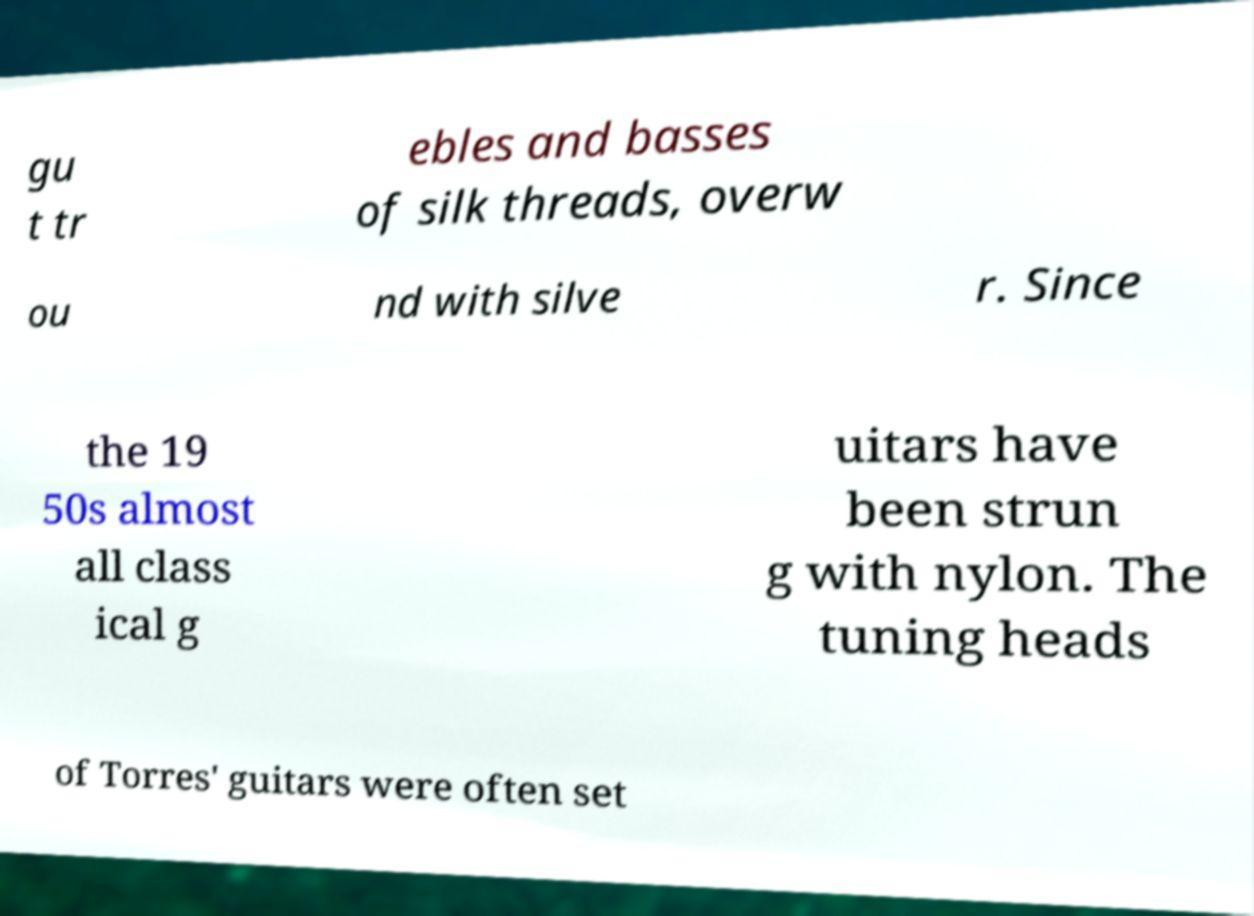Could you extract and type out the text from this image? gu t tr ebles and basses of silk threads, overw ou nd with silve r. Since the 19 50s almost all class ical g uitars have been strun g with nylon. The tuning heads of Torres' guitars were often set 